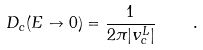Convert formula to latex. <formula><loc_0><loc_0><loc_500><loc_500>D _ { c } ( E \to 0 ) = \frac { 1 } { 2 \pi | v _ { c } ^ { L } | } \quad .</formula> 